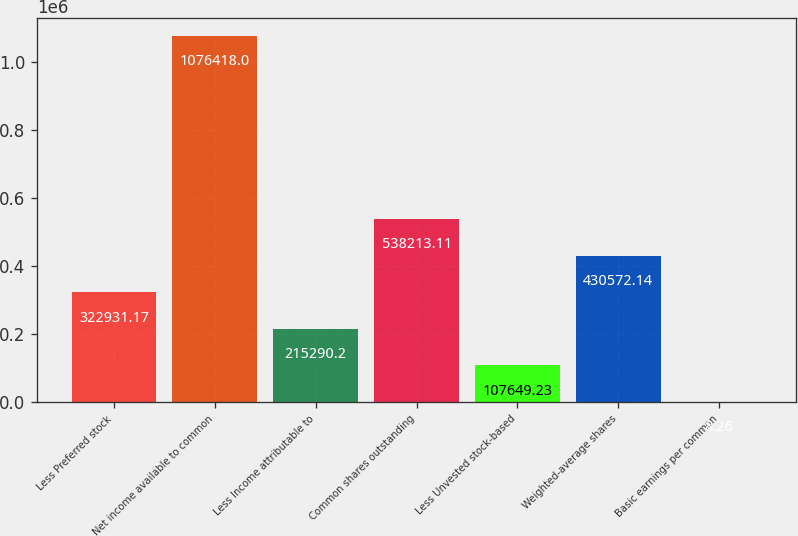Convert chart to OTSL. <chart><loc_0><loc_0><loc_500><loc_500><bar_chart><fcel>Less Preferred stock<fcel>Net income available to common<fcel>Less Income attributable to<fcel>Common shares outstanding<fcel>Less Unvested stock-based<fcel>Weighted-average shares<fcel>Basic earnings per common<nl><fcel>322931<fcel>1.07642e+06<fcel>215290<fcel>538213<fcel>107649<fcel>430572<fcel>8.26<nl></chart> 